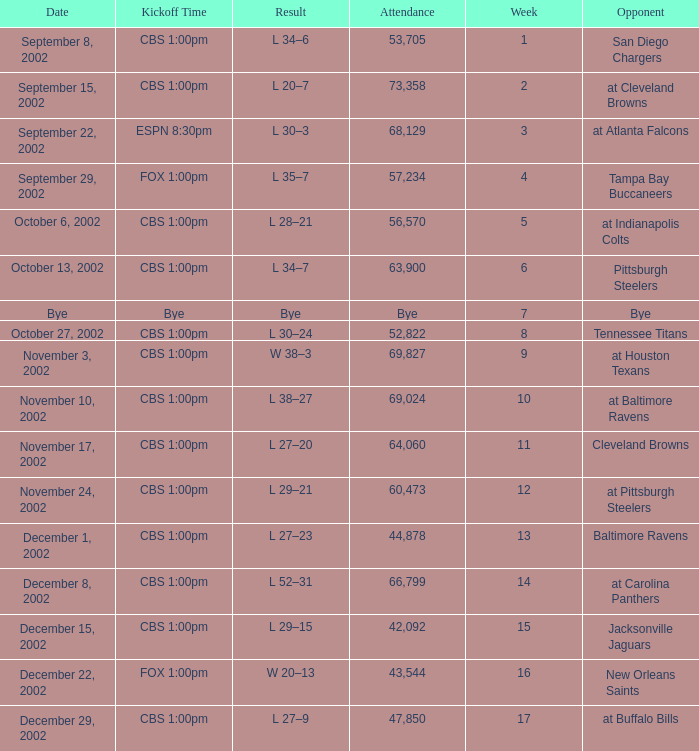What week was the opponent the San Diego Chargers? 1.0. 